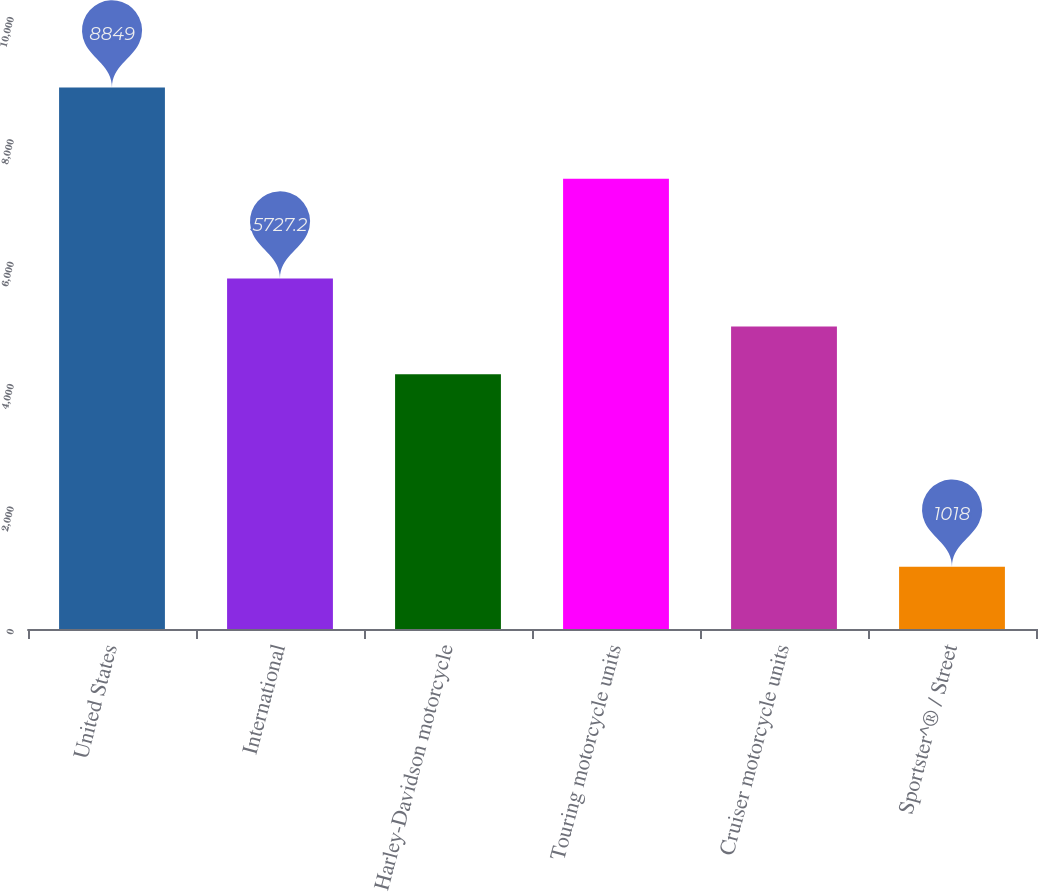Convert chart. <chart><loc_0><loc_0><loc_500><loc_500><bar_chart><fcel>United States<fcel>International<fcel>Harley-Davidson motorcycle<fcel>Touring motorcycle units<fcel>Cruiser motorcycle units<fcel>Sportster^® / Street<nl><fcel>8849<fcel>5727.2<fcel>4161<fcel>7358<fcel>4944.1<fcel>1018<nl></chart> 